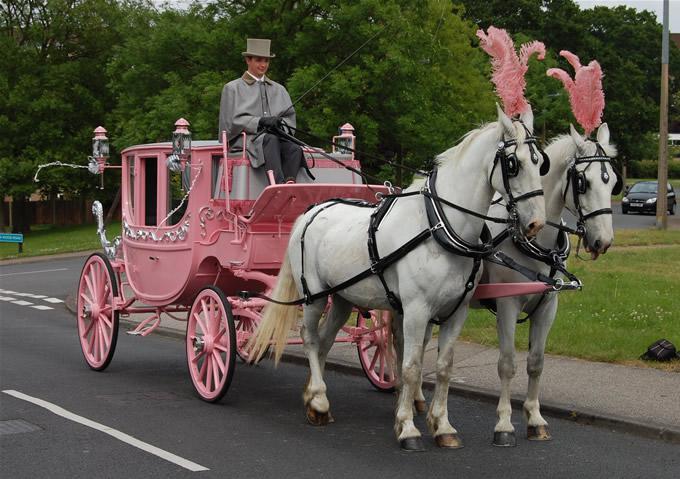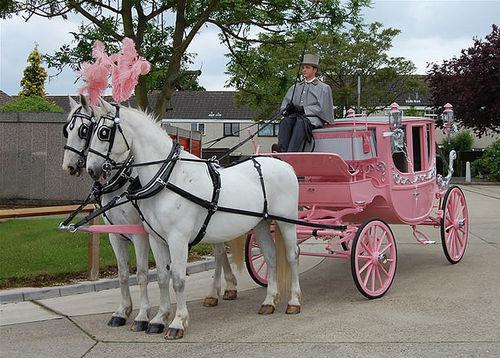The first image is the image on the left, the second image is the image on the right. Considering the images on both sides, is "At least two horses in the image on the left have pink head dresses." valid? Answer yes or no. Yes. The first image is the image on the left, the second image is the image on the right. Assess this claim about the two images: "One of the carriages is pulled by a single horse.". Correct or not? Answer yes or no. No. 